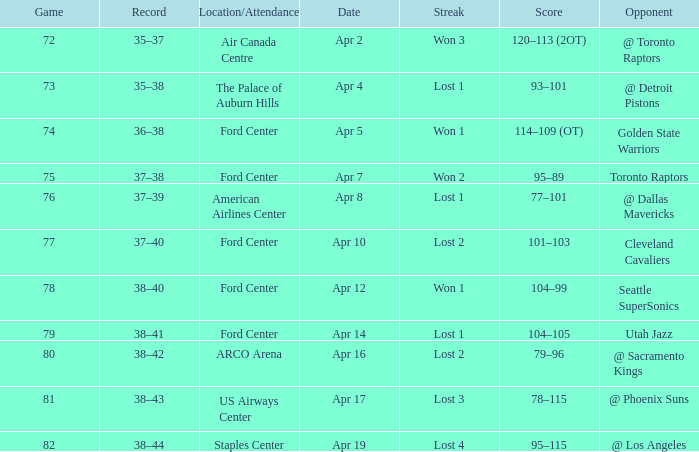What was the record for less than 78 games and a score of 114–109 (ot)? 36–38. 